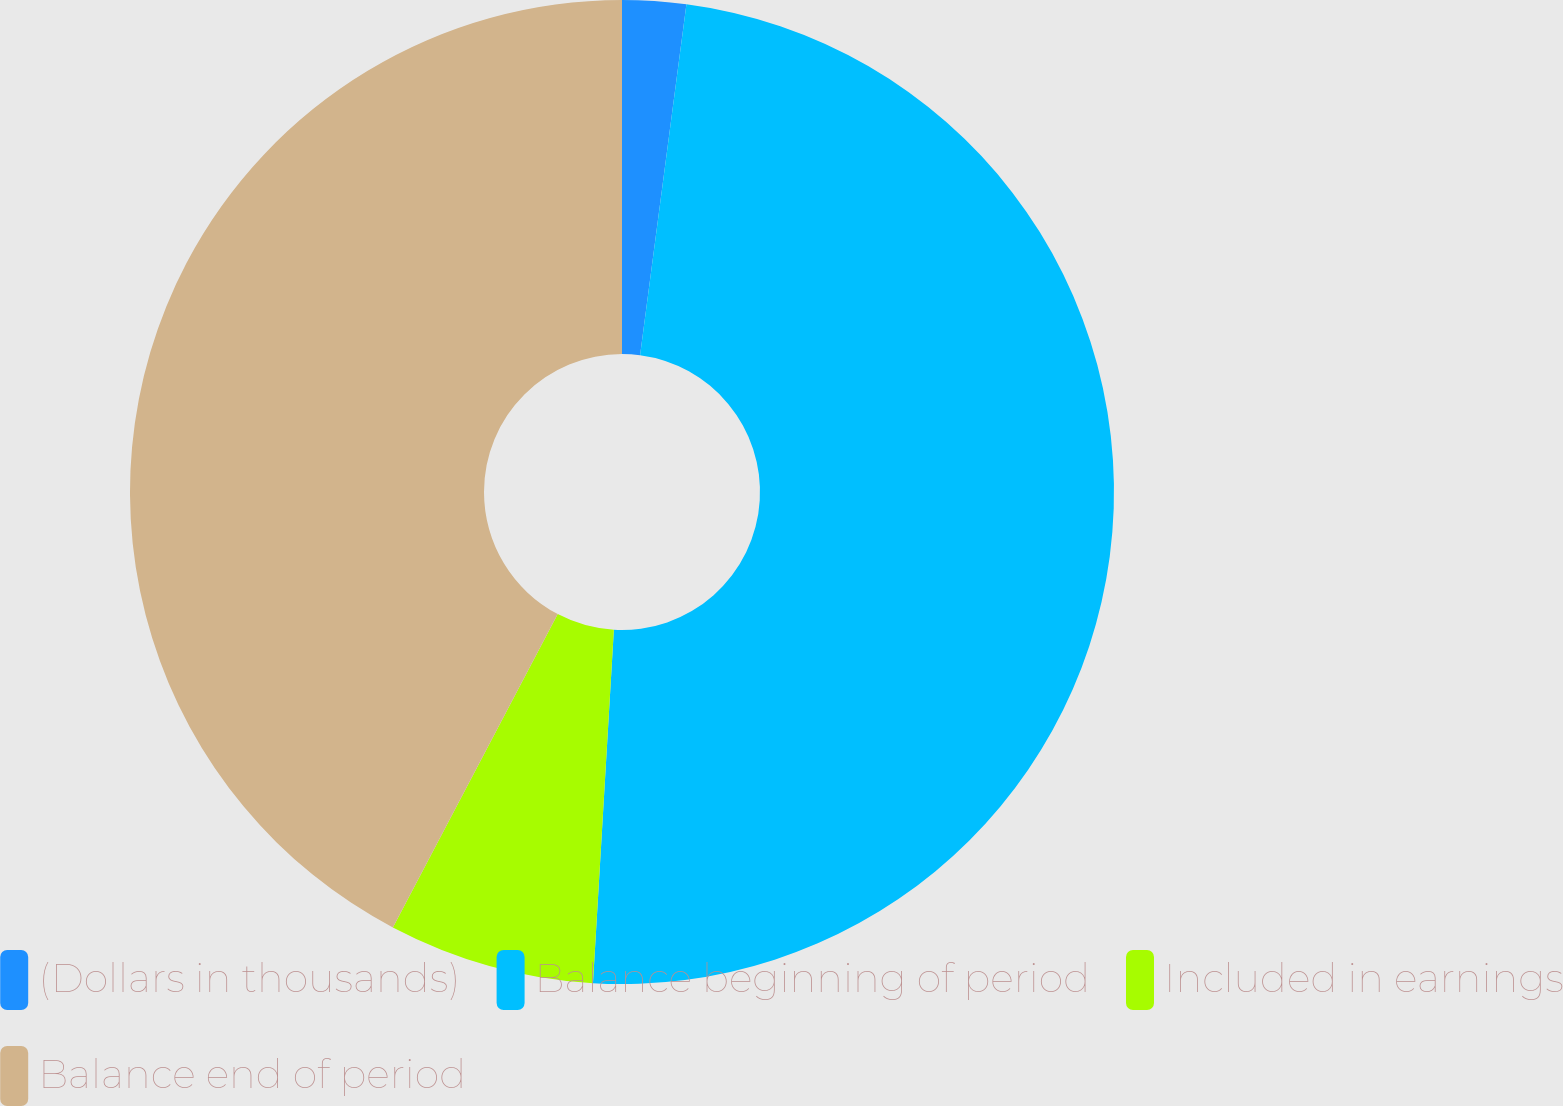Convert chart. <chart><loc_0><loc_0><loc_500><loc_500><pie_chart><fcel>(Dollars in thousands)<fcel>Balance beginning of period<fcel>Included in earnings<fcel>Balance end of period<nl><fcel>2.09%<fcel>48.85%<fcel>6.77%<fcel>42.29%<nl></chart> 